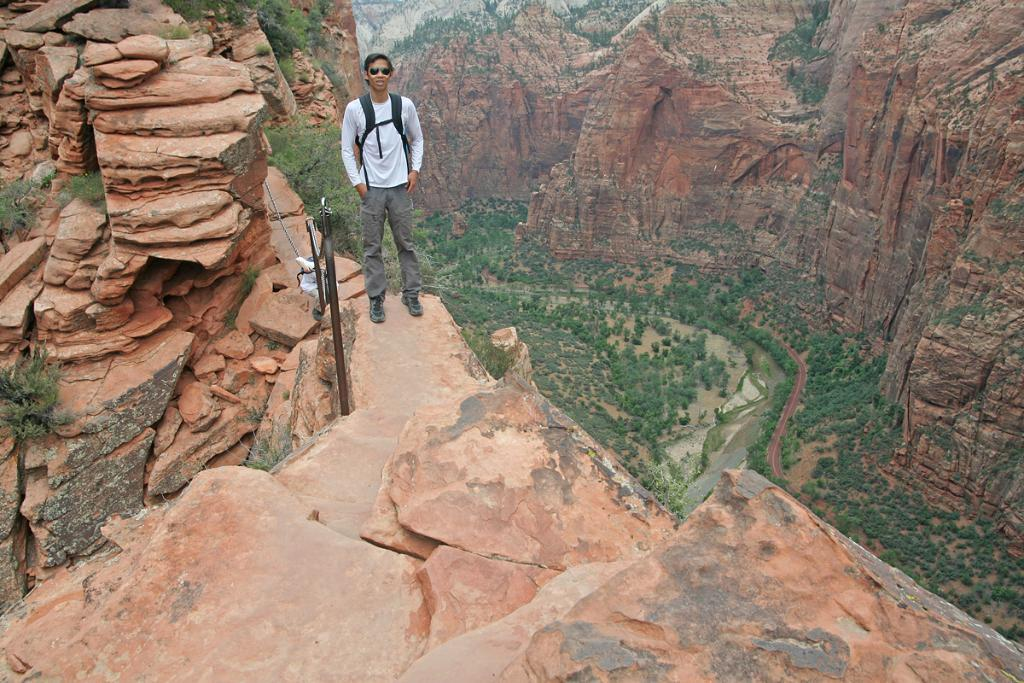What is the person in the image doing? The person is standing on a mountain in the image. What can be seen in the background of the image? There are trees visible in the image. What is located on the right side of the image? There is another mountain on the right side of the image. What type of rail can be seen running through the mountain in the image? There is no rail present in the image; it only shows a person standing on a mountain and trees in the background. 